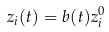Convert formula to latex. <formula><loc_0><loc_0><loc_500><loc_500>z _ { i } ( t ) = b ( t ) z _ { i } ^ { 0 }</formula> 